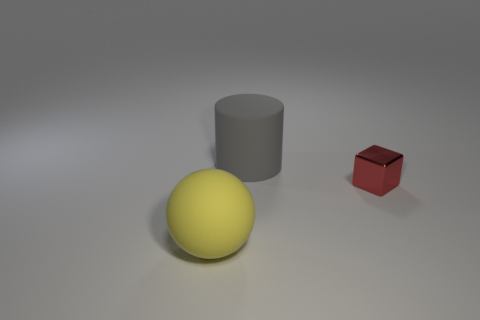Do the gray cylinder and the thing that is on the left side of the gray matte cylinder have the same size?
Your answer should be very brief. Yes. Are there any gray rubber cylinders that are to the right of the big thing that is in front of the tiny red metal cube?
Your answer should be very brief. Yes. There is a large matte object that is right of the large yellow matte thing; what shape is it?
Provide a succinct answer. Cylinder. There is a thing that is on the right side of the matte thing that is behind the big yellow rubber ball; what is its color?
Your response must be concise. Red. Does the cylinder have the same size as the matte sphere?
Provide a succinct answer. Yes. What number of other things have the same size as the yellow thing?
Provide a succinct answer. 1. There is a cylinder that is made of the same material as the yellow sphere; what color is it?
Your answer should be very brief. Gray. Is the number of tiny red things less than the number of big red matte cylinders?
Make the answer very short. No. How many yellow objects are either large objects or big shiny spheres?
Offer a very short reply. 1. What number of objects are on the right side of the large gray matte object and in front of the small block?
Offer a very short reply. 0. 